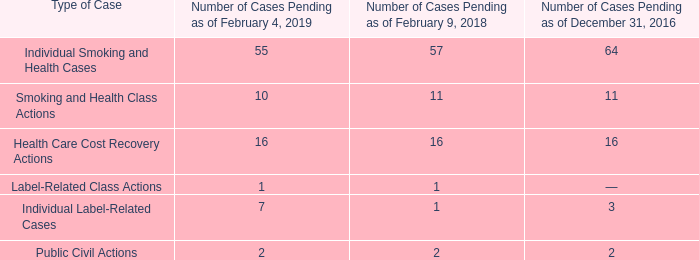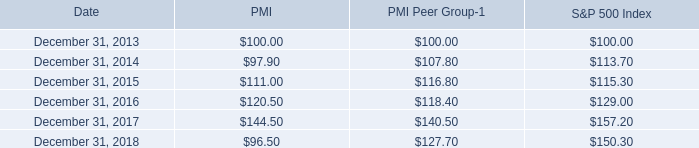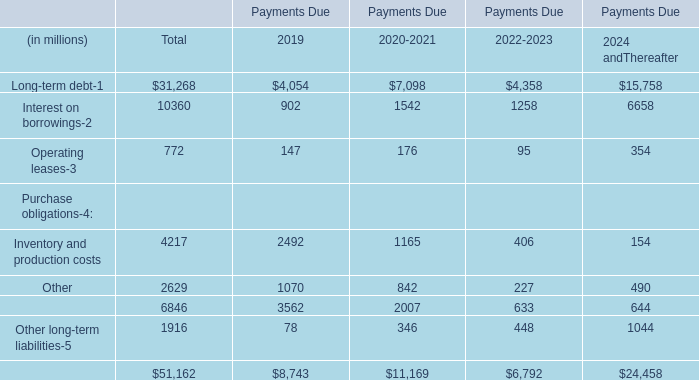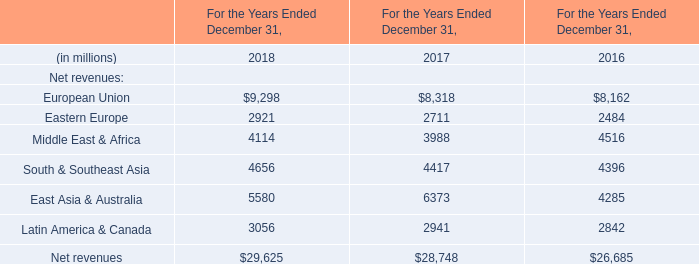What is the sum of Operating leases in 2019 and Eastern Europe in 2018? (in million) 
Computations: (147 + 2921)
Answer: 3068.0. 